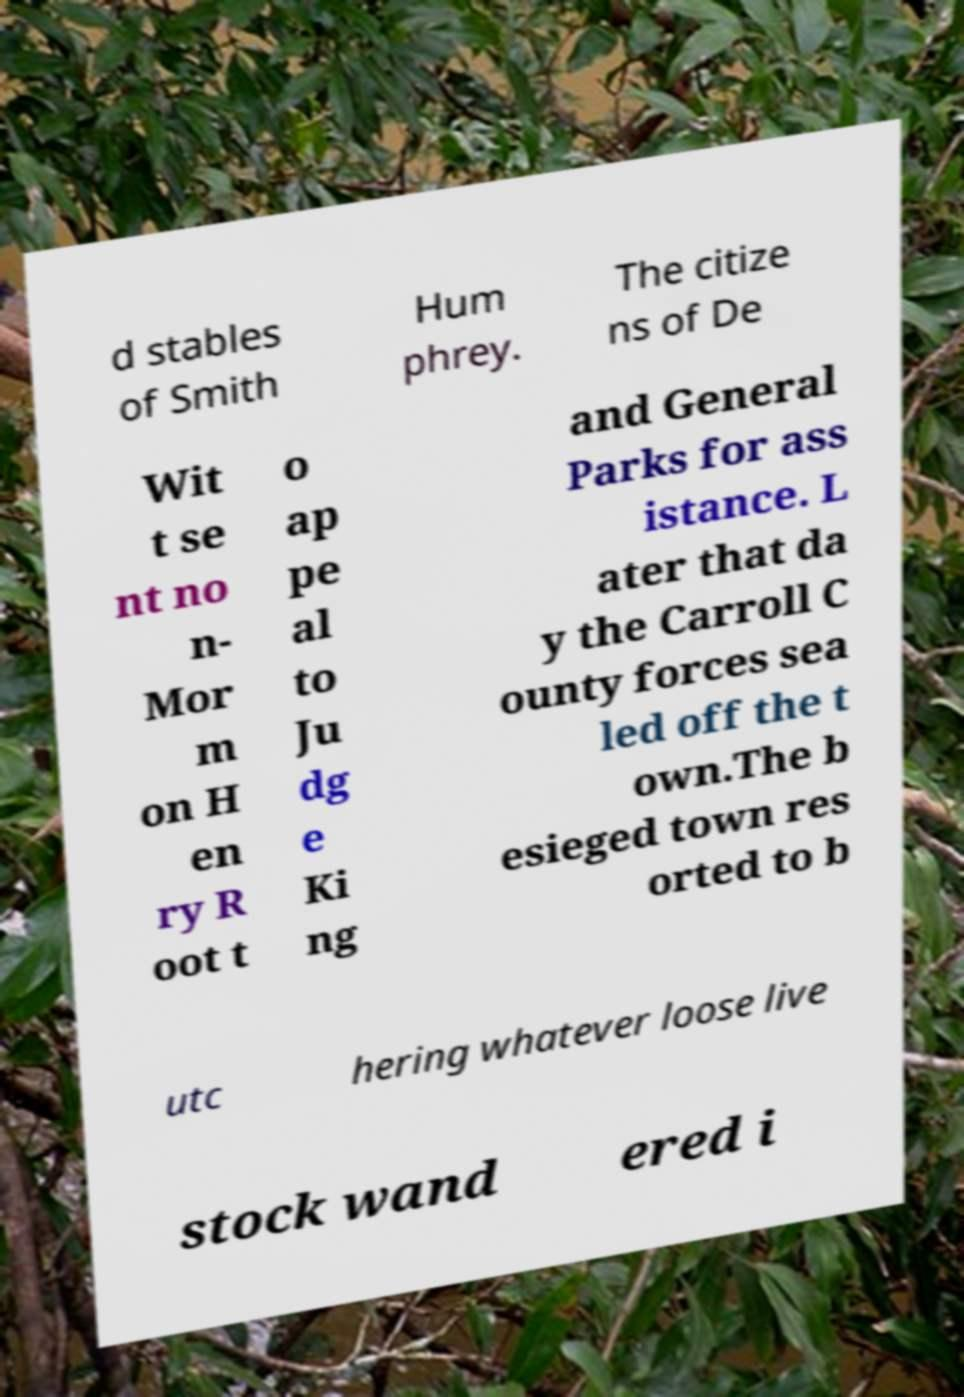Please identify and transcribe the text found in this image. d stables of Smith Hum phrey. The citize ns of De Wit t se nt no n- Mor m on H en ry R oot t o ap pe al to Ju dg e Ki ng and General Parks for ass istance. L ater that da y the Carroll C ounty forces sea led off the t own.The b esieged town res orted to b utc hering whatever loose live stock wand ered i 